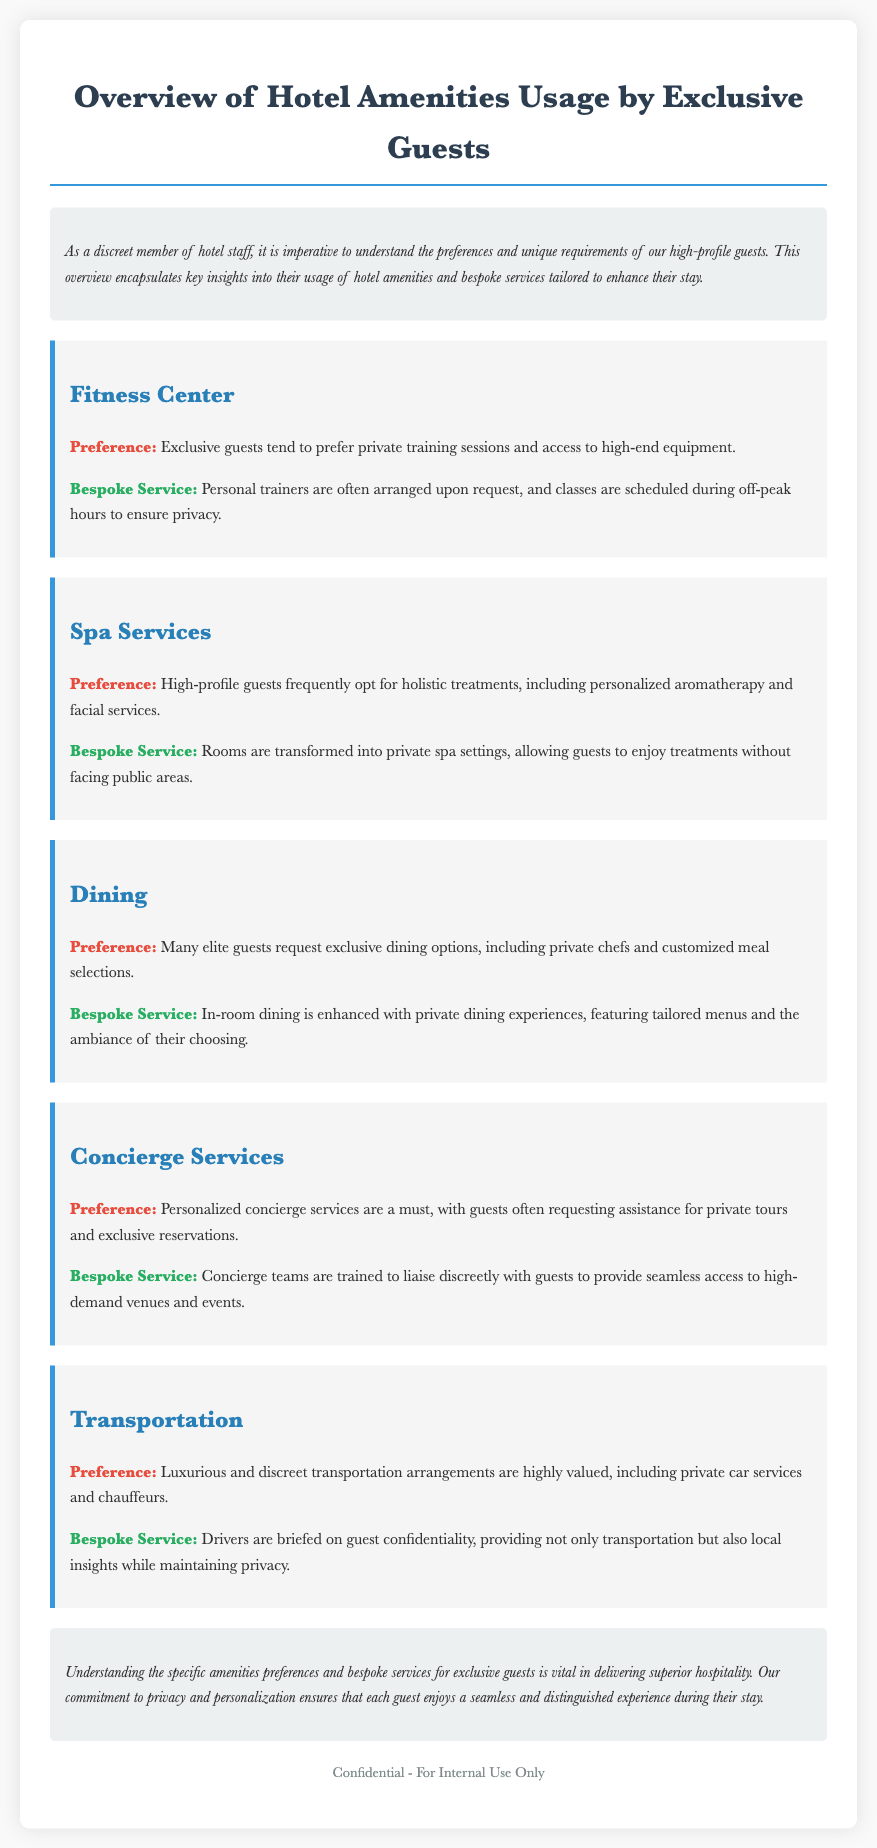What are the preferences of exclusive guests in the Fitness Center? Exclusive guests prefer private training sessions and access to high-end equipment.
Answer: Private training sessions and high-end equipment What bespoke service is offered in the Spa Services section? A bespoke service includes transforming rooms into private spa settings for treatments.
Answer: Private spa settings What specific dining option do elite guests often request? Elite guests often request exclusive dining options including private chefs.
Answer: Private chefs How does the document categorize the services offered? The document categorizes services under headings like Fitness Center, Spa Services, Dining, Concierge Services, and Transportation.
Answer: By service type What is the role of personal trainers mentioned in the Fitness Center section? The role of personal trainers is to be arranged upon request for exclusive guests.
Answer: Arranged upon request What aspect do high-profile guests value in Transportation? High-profile guests value luxurious and discreet transportation arrangements.
Answer: Luxurious and discreet What does the conclusion emphasize about guest experience? The conclusion emphasizes the importance of understanding preferences and providing superior hospitality.
Answer: Superior hospitality What is a key service provided by concierge teams? Concierge teams provide seamless access to high-demand venues and events discreetly.
Answer: Seamless access to high-demand venues What stylistic feature is consistently used for the preferences and bespoke sections? The stylistic feature is the use of bold text before each category in the preferences and bespoke sections.
Answer: Bold text 